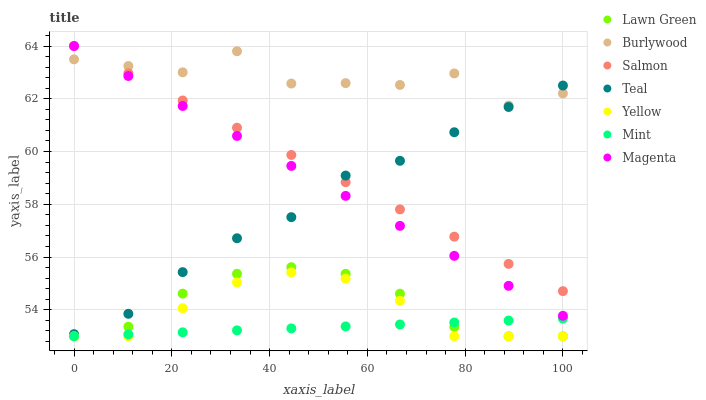Does Mint have the minimum area under the curve?
Answer yes or no. Yes. Does Burlywood have the maximum area under the curve?
Answer yes or no. Yes. Does Salmon have the minimum area under the curve?
Answer yes or no. No. Does Salmon have the maximum area under the curve?
Answer yes or no. No. Is Salmon the smoothest?
Answer yes or no. Yes. Is Burlywood the roughest?
Answer yes or no. Yes. Is Burlywood the smoothest?
Answer yes or no. No. Is Salmon the roughest?
Answer yes or no. No. Does Lawn Green have the lowest value?
Answer yes or no. Yes. Does Salmon have the lowest value?
Answer yes or no. No. Does Magenta have the highest value?
Answer yes or no. Yes. Does Burlywood have the highest value?
Answer yes or no. No. Is Yellow less than Salmon?
Answer yes or no. Yes. Is Magenta greater than Yellow?
Answer yes or no. Yes. Does Lawn Green intersect Yellow?
Answer yes or no. Yes. Is Lawn Green less than Yellow?
Answer yes or no. No. Is Lawn Green greater than Yellow?
Answer yes or no. No. Does Yellow intersect Salmon?
Answer yes or no. No. 